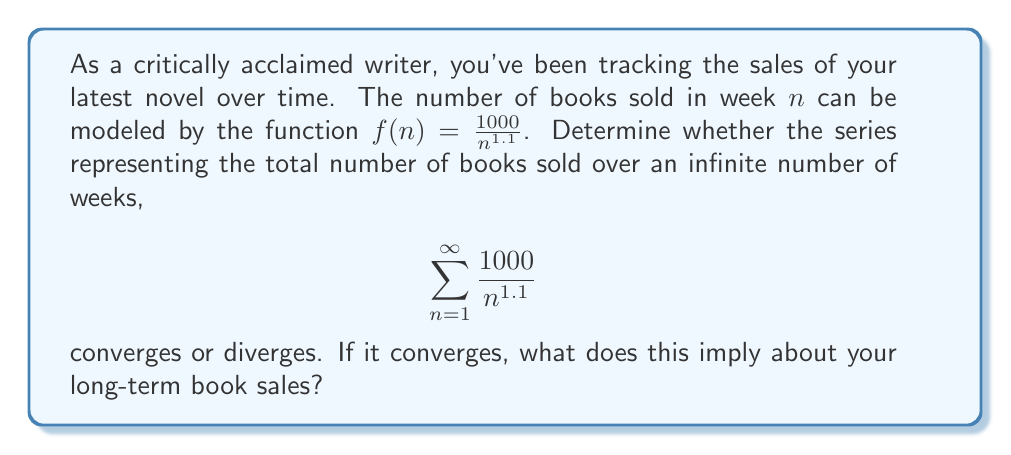Give your solution to this math problem. To analyze the convergence of this series, we'll use the p-series test:

1) The general form of a p-series is $\sum_{n=1}^{\infty} \frac{1}{n^p}$.

2) Our series can be rewritten as $1000 \sum_{n=1}^{\infty} \frac{1}{n^{1.1}}$.

3) The constant 1000 doesn't affect convergence, so we focus on $\sum_{n=1}^{\infty} \frac{1}{n^{1.1}}$.

4) This is a p-series with $p = 1.1$.

5) For a p-series:
   - If $p > 1$, the series converges.
   - If $p \leq 1$, the series diverges.

6) Since $1.1 > 1$, our series converges.

7) Convergence implies that the sum of all terms approaches a finite value as n approaches infinity.

8) In the context of book sales, this means that while sales continue indefinitely, the total number of books sold over all time will approach a finite limit.

9) The rate of sales decreases rapidly enough that even over an infinite time, total sales won't exceed a certain amount.
Answer: The series converges, implying total book sales will approach a finite limit over infinite time. 